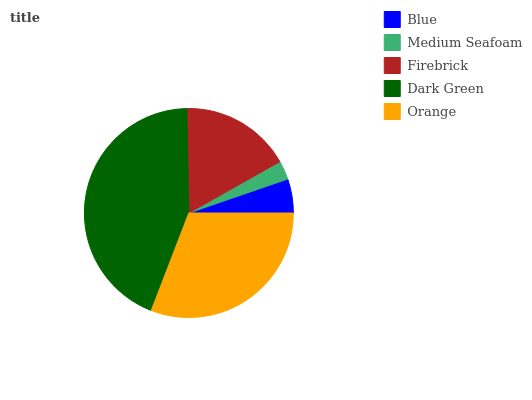Is Medium Seafoam the minimum?
Answer yes or no. Yes. Is Dark Green the maximum?
Answer yes or no. Yes. Is Firebrick the minimum?
Answer yes or no. No. Is Firebrick the maximum?
Answer yes or no. No. Is Firebrick greater than Medium Seafoam?
Answer yes or no. Yes. Is Medium Seafoam less than Firebrick?
Answer yes or no. Yes. Is Medium Seafoam greater than Firebrick?
Answer yes or no. No. Is Firebrick less than Medium Seafoam?
Answer yes or no. No. Is Firebrick the high median?
Answer yes or no. Yes. Is Firebrick the low median?
Answer yes or no. Yes. Is Blue the high median?
Answer yes or no. No. Is Orange the low median?
Answer yes or no. No. 